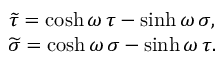Convert formula to latex. <formula><loc_0><loc_0><loc_500><loc_500>\begin{array} { c } { { \widetilde { \tau } = \cosh \omega \, \tau - \sinh \omega \, \sigma , } } \\ { { \widetilde { \sigma } = \cosh \omega \, \sigma - \sinh \omega \, \tau . } } \end{array}</formula> 